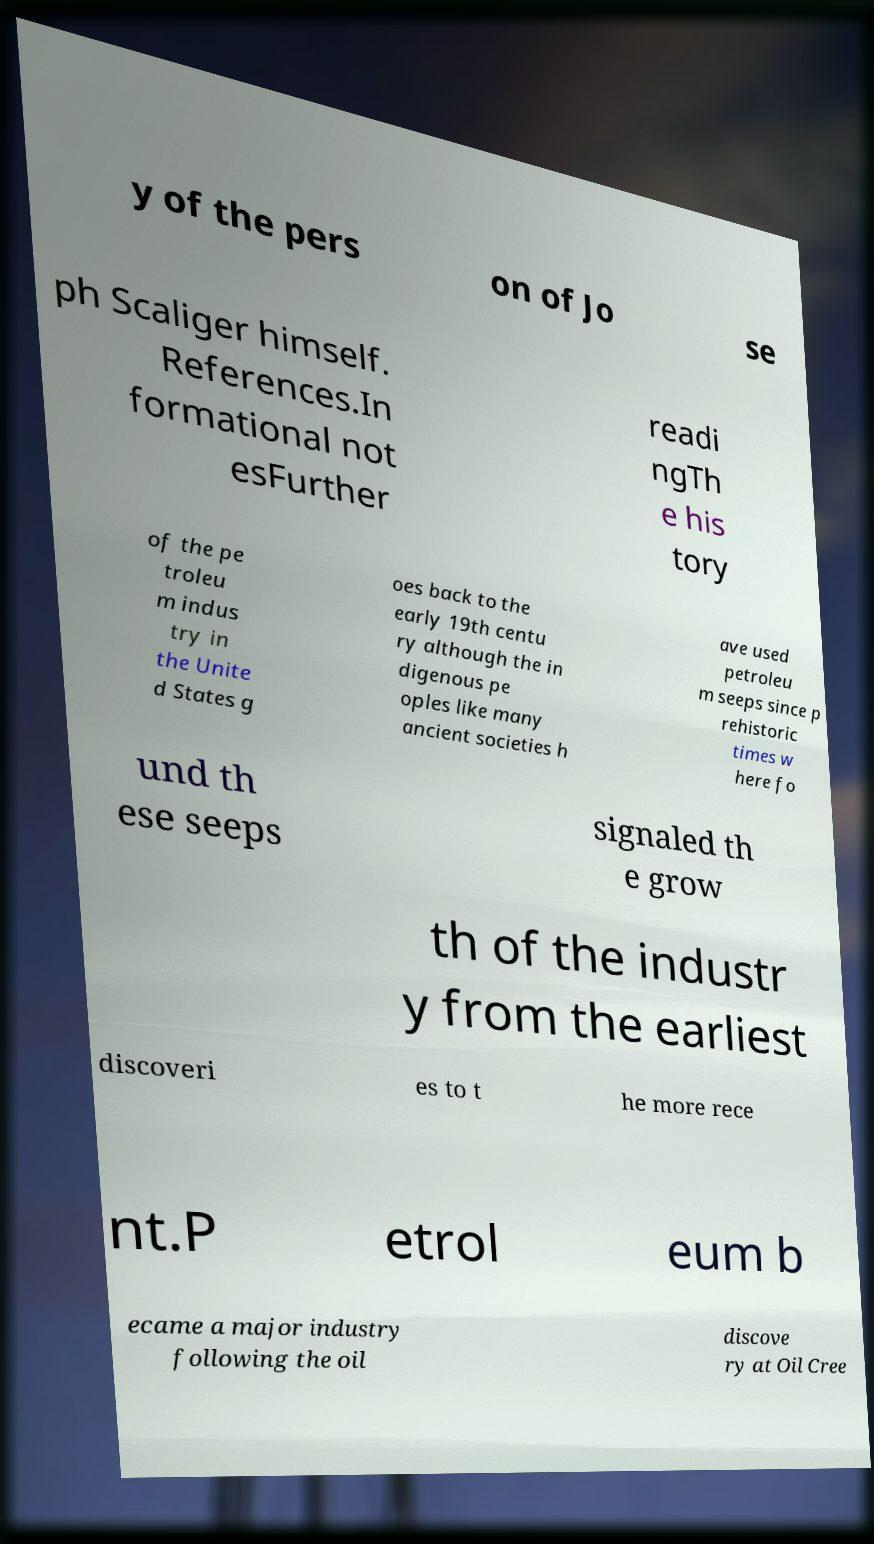There's text embedded in this image that I need extracted. Can you transcribe it verbatim? y of the pers on of Jo se ph Scaliger himself. References.In formational not esFurther readi ngTh e his tory of the pe troleu m indus try in the Unite d States g oes back to the early 19th centu ry although the in digenous pe oples like many ancient societies h ave used petroleu m seeps since p rehistoric times w here fo und th ese seeps signaled th e grow th of the industr y from the earliest discoveri es to t he more rece nt.P etrol eum b ecame a major industry following the oil discove ry at Oil Cree 